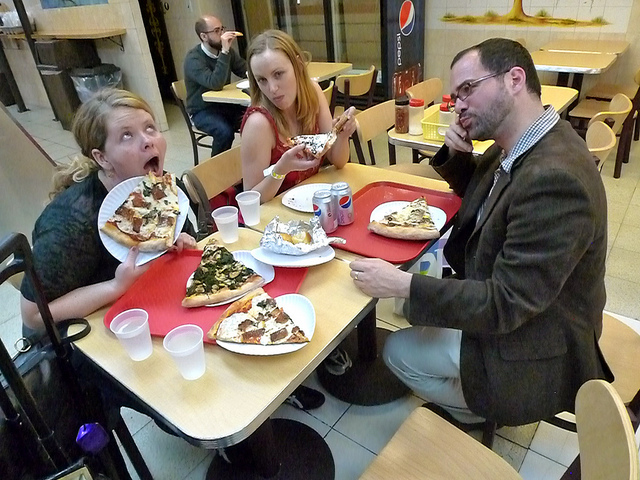<image>Are the people eating with chopsticks? No, the people are not eating with chopsticks. Are the people eating with chopsticks? No, the people are not eating with chopsticks. 